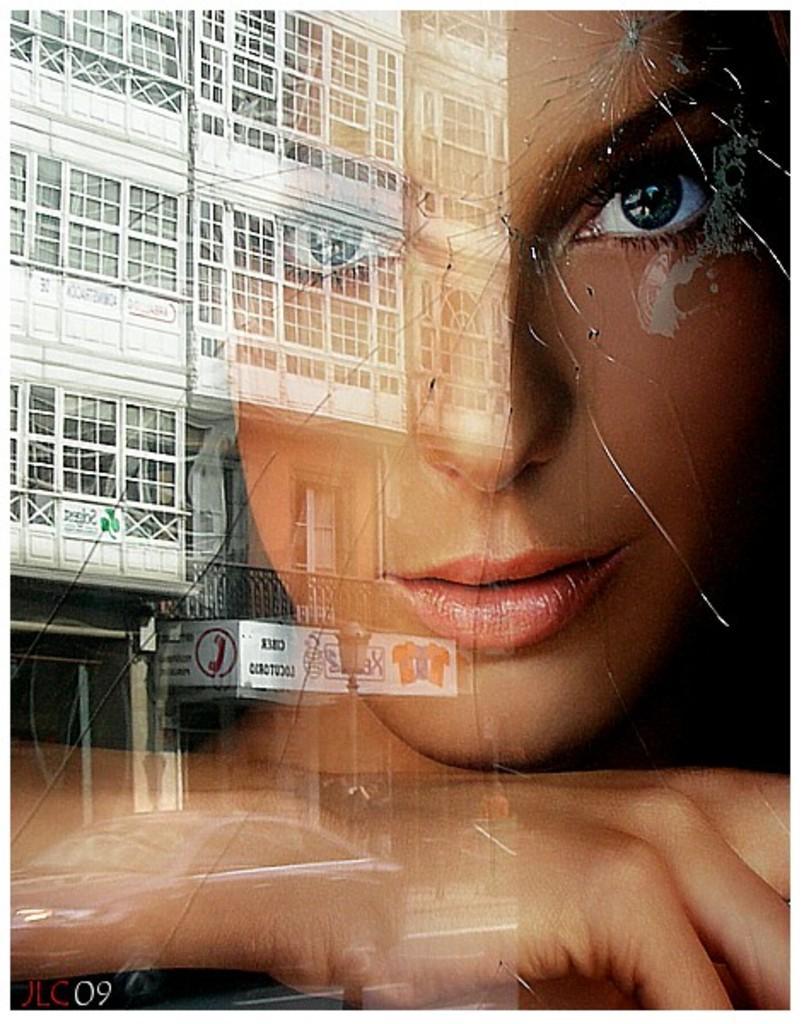In one or two sentences, can you explain what this image depicts? In this picture we can see the building and shadow of one girl face. 